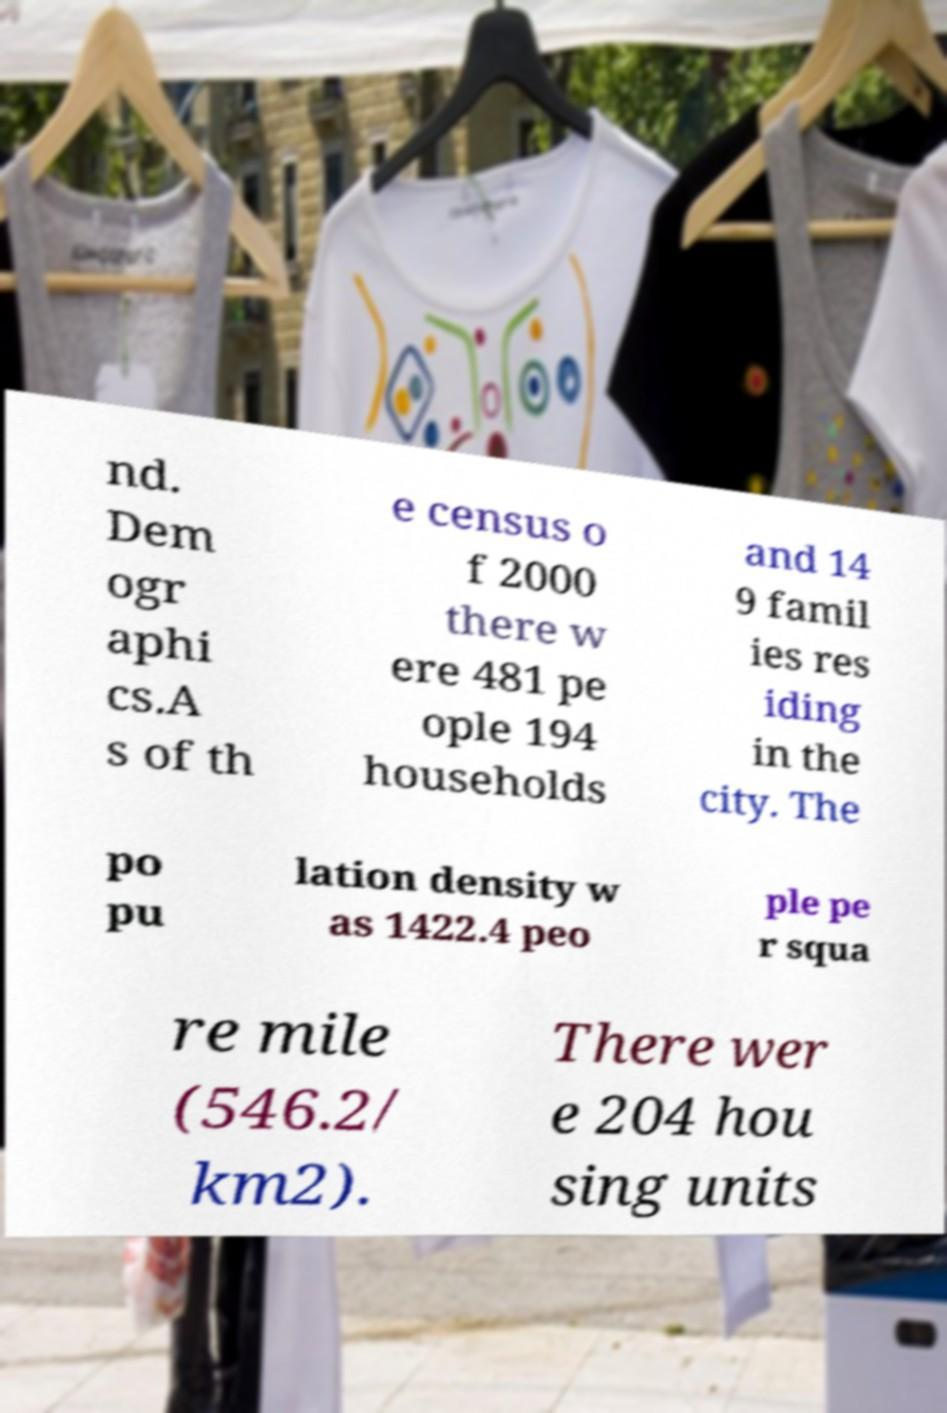Can you read and provide the text displayed in the image?This photo seems to have some interesting text. Can you extract and type it out for me? nd. Dem ogr aphi cs.A s of th e census o f 2000 there w ere 481 pe ople 194 households and 14 9 famil ies res iding in the city. The po pu lation density w as 1422.4 peo ple pe r squa re mile (546.2/ km2). There wer e 204 hou sing units 